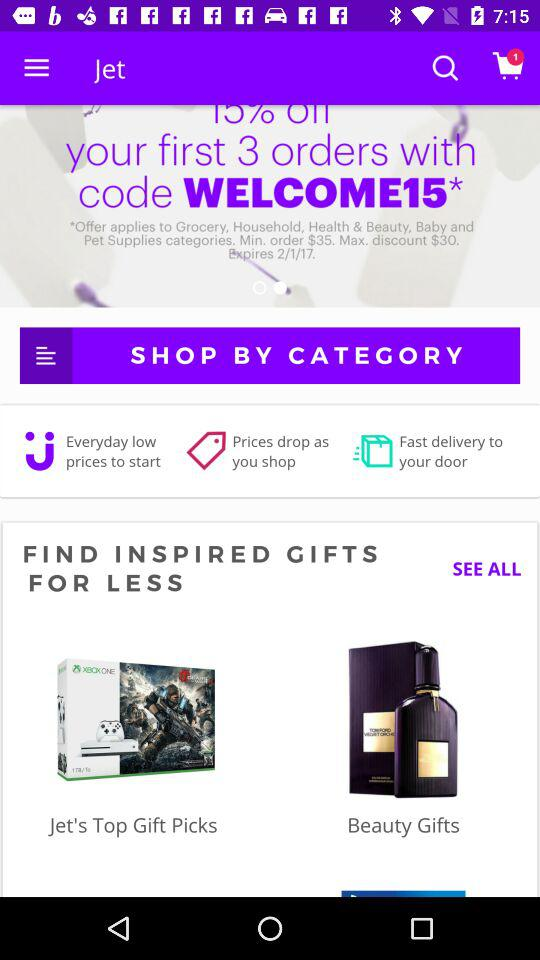What is the code? The code is "WELCOME15". 